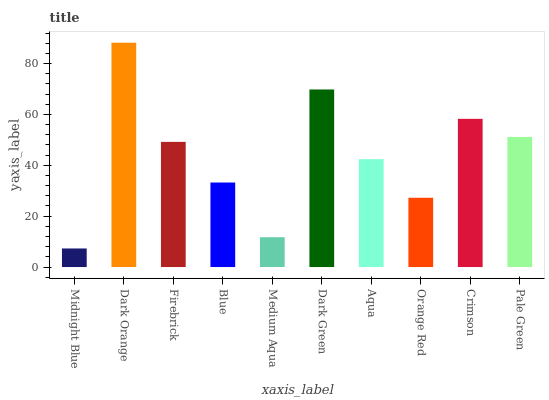Is Midnight Blue the minimum?
Answer yes or no. Yes. Is Dark Orange the maximum?
Answer yes or no. Yes. Is Firebrick the minimum?
Answer yes or no. No. Is Firebrick the maximum?
Answer yes or no. No. Is Dark Orange greater than Firebrick?
Answer yes or no. Yes. Is Firebrick less than Dark Orange?
Answer yes or no. Yes. Is Firebrick greater than Dark Orange?
Answer yes or no. No. Is Dark Orange less than Firebrick?
Answer yes or no. No. Is Firebrick the high median?
Answer yes or no. Yes. Is Aqua the low median?
Answer yes or no. Yes. Is Crimson the high median?
Answer yes or no. No. Is Dark Orange the low median?
Answer yes or no. No. 